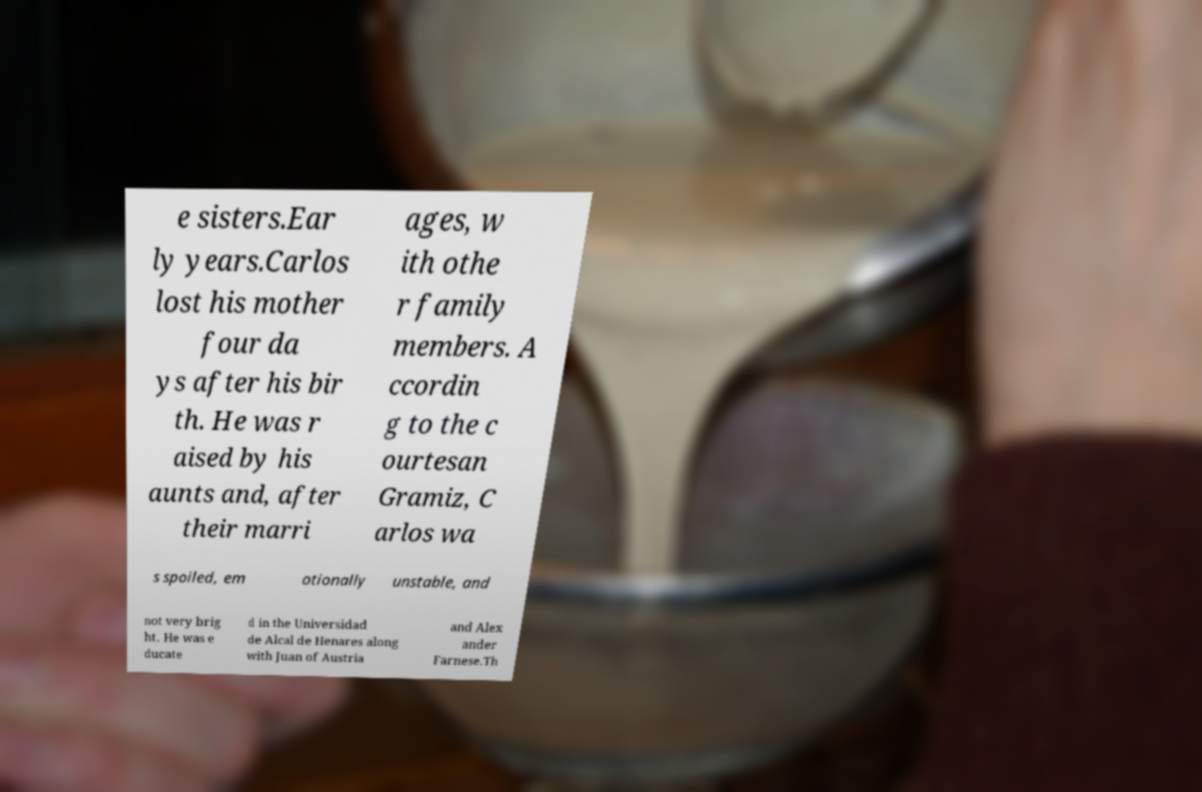I need the written content from this picture converted into text. Can you do that? e sisters.Ear ly years.Carlos lost his mother four da ys after his bir th. He was r aised by his aunts and, after their marri ages, w ith othe r family members. A ccordin g to the c ourtesan Gramiz, C arlos wa s spoiled, em otionally unstable, and not very brig ht. He was e ducate d in the Universidad de Alcal de Henares along with Juan of Austria and Alex ander Farnese.Th 